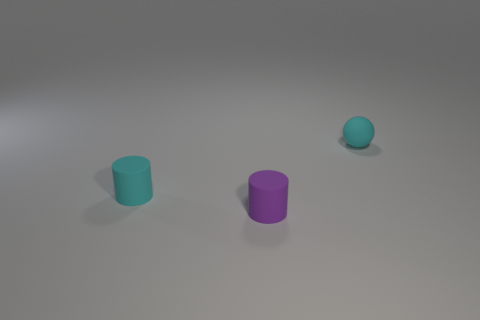There is another small cylinder that is made of the same material as the cyan cylinder; what color is it?
Your answer should be very brief. Purple. How many things are matte objects that are to the right of the purple rubber cylinder or tiny cyan matte objects behind the tiny cyan matte cylinder?
Your answer should be compact. 1. Are there an equal number of purple rubber things right of the purple matte cylinder and small brown rubber cylinders?
Provide a short and direct response. Yes. Is there anything else that is the same shape as the purple thing?
Offer a terse response. Yes. Is the shape of the tiny purple rubber object the same as the cyan thing that is in front of the small matte ball?
Make the answer very short. Yes. What size is the other rubber thing that is the same shape as the purple object?
Offer a very short reply. Small. How many other things are made of the same material as the purple cylinder?
Provide a succinct answer. 2. There is a tiny thing to the right of the tiny purple rubber thing; is it the same color as the rubber cylinder behind the tiny purple thing?
Give a very brief answer. Yes. Are there more cyan things in front of the ball than brown shiny objects?
Offer a very short reply. Yes. What number of other objects are the same color as the tiny ball?
Offer a very short reply. 1. 